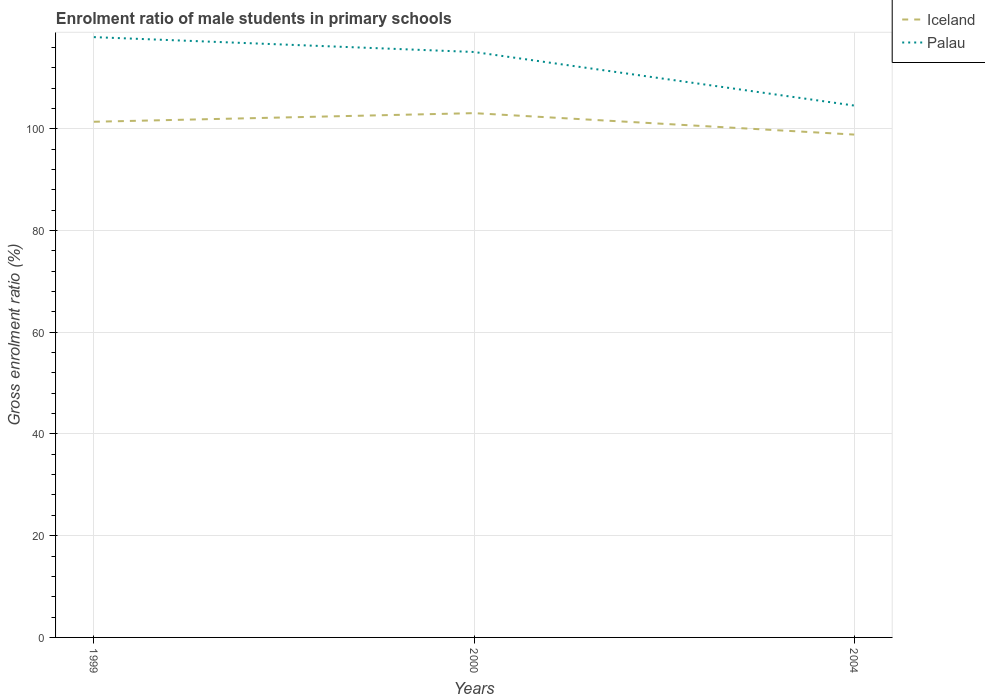How many different coloured lines are there?
Offer a terse response. 2. Does the line corresponding to Palau intersect with the line corresponding to Iceland?
Keep it short and to the point. No. Across all years, what is the maximum enrolment ratio of male students in primary schools in Palau?
Your response must be concise. 104.55. What is the total enrolment ratio of male students in primary schools in Palau in the graph?
Give a very brief answer. 10.53. What is the difference between the highest and the second highest enrolment ratio of male students in primary schools in Iceland?
Provide a short and direct response. 4.21. Is the enrolment ratio of male students in primary schools in Iceland strictly greater than the enrolment ratio of male students in primary schools in Palau over the years?
Make the answer very short. Yes. What is the difference between two consecutive major ticks on the Y-axis?
Keep it short and to the point. 20. Are the values on the major ticks of Y-axis written in scientific E-notation?
Give a very brief answer. No. Does the graph contain any zero values?
Your answer should be very brief. No. Does the graph contain grids?
Make the answer very short. Yes. What is the title of the graph?
Your response must be concise. Enrolment ratio of male students in primary schools. Does "Ukraine" appear as one of the legend labels in the graph?
Your answer should be compact. No. What is the label or title of the Y-axis?
Make the answer very short. Gross enrolment ratio (%). What is the Gross enrolment ratio (%) of Iceland in 1999?
Provide a succinct answer. 101.37. What is the Gross enrolment ratio (%) of Palau in 1999?
Offer a very short reply. 118. What is the Gross enrolment ratio (%) of Iceland in 2000?
Keep it short and to the point. 103.06. What is the Gross enrolment ratio (%) in Palau in 2000?
Offer a terse response. 115.08. What is the Gross enrolment ratio (%) in Iceland in 2004?
Keep it short and to the point. 98.84. What is the Gross enrolment ratio (%) in Palau in 2004?
Your response must be concise. 104.55. Across all years, what is the maximum Gross enrolment ratio (%) of Iceland?
Offer a terse response. 103.06. Across all years, what is the maximum Gross enrolment ratio (%) in Palau?
Ensure brevity in your answer.  118. Across all years, what is the minimum Gross enrolment ratio (%) in Iceland?
Provide a succinct answer. 98.84. Across all years, what is the minimum Gross enrolment ratio (%) in Palau?
Provide a succinct answer. 104.55. What is the total Gross enrolment ratio (%) in Iceland in the graph?
Your answer should be very brief. 303.27. What is the total Gross enrolment ratio (%) of Palau in the graph?
Your response must be concise. 337.63. What is the difference between the Gross enrolment ratio (%) in Iceland in 1999 and that in 2000?
Your answer should be compact. -1.69. What is the difference between the Gross enrolment ratio (%) in Palau in 1999 and that in 2000?
Your answer should be compact. 2.92. What is the difference between the Gross enrolment ratio (%) of Iceland in 1999 and that in 2004?
Your response must be concise. 2.52. What is the difference between the Gross enrolment ratio (%) in Palau in 1999 and that in 2004?
Offer a very short reply. 13.45. What is the difference between the Gross enrolment ratio (%) in Iceland in 2000 and that in 2004?
Offer a terse response. 4.21. What is the difference between the Gross enrolment ratio (%) in Palau in 2000 and that in 2004?
Provide a short and direct response. 10.53. What is the difference between the Gross enrolment ratio (%) of Iceland in 1999 and the Gross enrolment ratio (%) of Palau in 2000?
Offer a very short reply. -13.71. What is the difference between the Gross enrolment ratio (%) in Iceland in 1999 and the Gross enrolment ratio (%) in Palau in 2004?
Your response must be concise. -3.18. What is the difference between the Gross enrolment ratio (%) in Iceland in 2000 and the Gross enrolment ratio (%) in Palau in 2004?
Keep it short and to the point. -1.49. What is the average Gross enrolment ratio (%) in Iceland per year?
Make the answer very short. 101.09. What is the average Gross enrolment ratio (%) in Palau per year?
Keep it short and to the point. 112.54. In the year 1999, what is the difference between the Gross enrolment ratio (%) of Iceland and Gross enrolment ratio (%) of Palau?
Your answer should be very brief. -16.64. In the year 2000, what is the difference between the Gross enrolment ratio (%) in Iceland and Gross enrolment ratio (%) in Palau?
Offer a terse response. -12.02. In the year 2004, what is the difference between the Gross enrolment ratio (%) of Iceland and Gross enrolment ratio (%) of Palau?
Ensure brevity in your answer.  -5.71. What is the ratio of the Gross enrolment ratio (%) in Iceland in 1999 to that in 2000?
Give a very brief answer. 0.98. What is the ratio of the Gross enrolment ratio (%) in Palau in 1999 to that in 2000?
Make the answer very short. 1.03. What is the ratio of the Gross enrolment ratio (%) of Iceland in 1999 to that in 2004?
Your response must be concise. 1.03. What is the ratio of the Gross enrolment ratio (%) in Palau in 1999 to that in 2004?
Provide a short and direct response. 1.13. What is the ratio of the Gross enrolment ratio (%) of Iceland in 2000 to that in 2004?
Offer a very short reply. 1.04. What is the ratio of the Gross enrolment ratio (%) of Palau in 2000 to that in 2004?
Your response must be concise. 1.1. What is the difference between the highest and the second highest Gross enrolment ratio (%) of Iceland?
Keep it short and to the point. 1.69. What is the difference between the highest and the second highest Gross enrolment ratio (%) of Palau?
Offer a terse response. 2.92. What is the difference between the highest and the lowest Gross enrolment ratio (%) of Iceland?
Your answer should be compact. 4.21. What is the difference between the highest and the lowest Gross enrolment ratio (%) of Palau?
Make the answer very short. 13.45. 